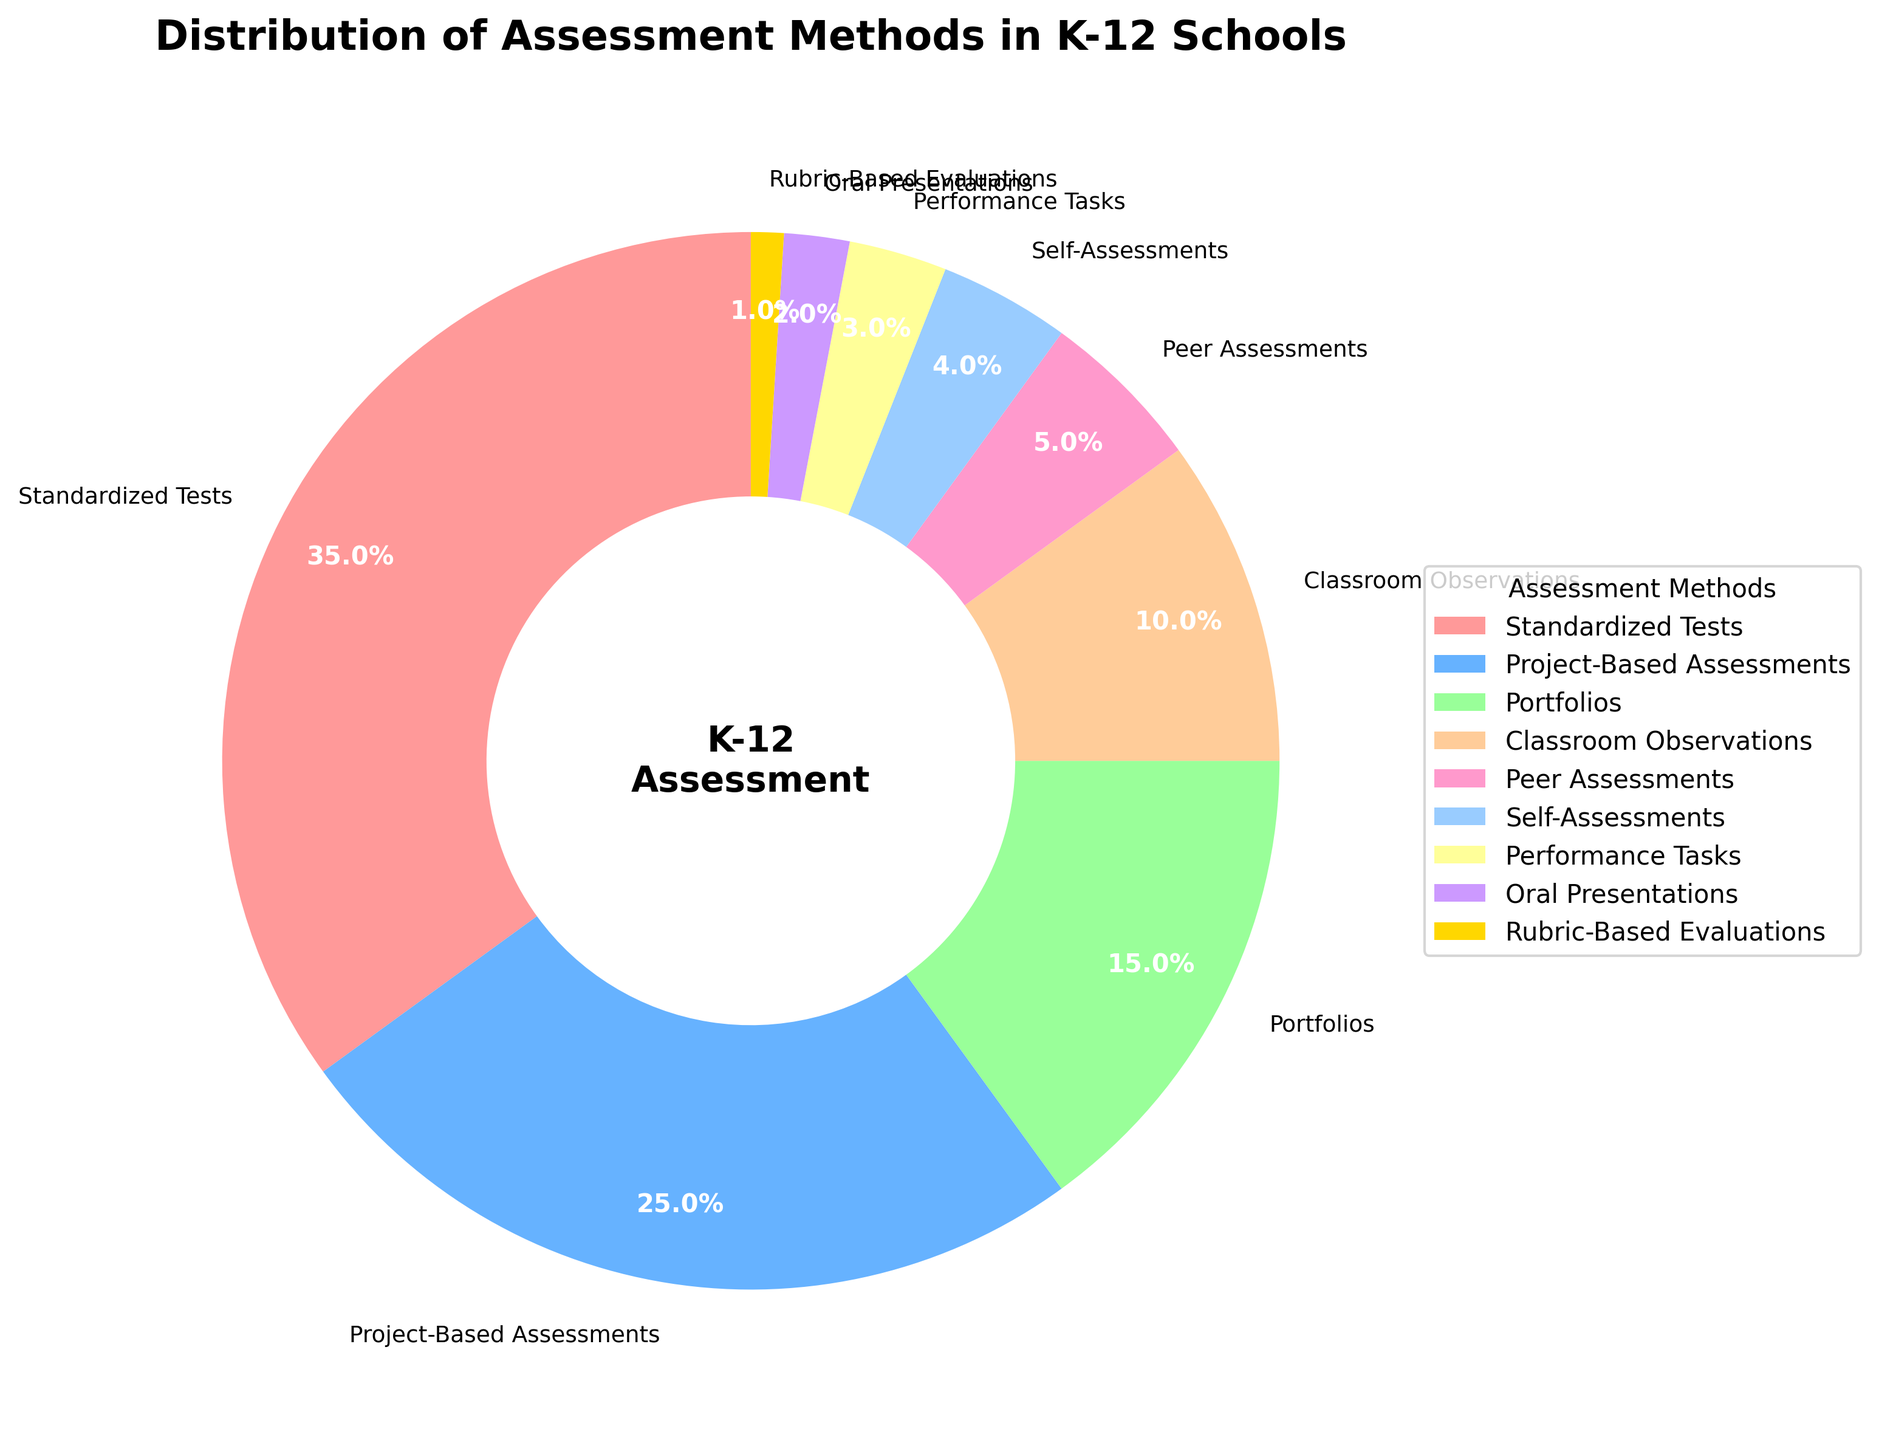What is the percentage of K-12 schools that use Standardized Tests for assessment? Standardized Tests takes up 35% of the assessment methods as indicated on the pie chart.
Answer: 35% What is the combined percentage of schools using Project-Based Assessments, Portfolios, and Classroom Observations? Adding up the percentages for Project-Based Assessments (25%), Portfolios (15%), and Classroom Observations (10%) gives us 25% + 15% + 10% = 50%.
Answer: 50% Which two assessment methods combined have a lower percentage than Standardized Tests alone? Performance Tasks (3%) combined with Oral Presentations (2%) equates to 3% + 2% = 5%, which is significantly lower than Standardized Tests (35%).
Answer: Performance Tasks and Oral Presentations How much more popular are Project-Based Assessments compared to Peer Assessments? Project-Based Assessments are at 25%, and Peer Assessments are at 5%. The difference is 25% - 5% = 20%.
Answer: 20% Which assessment method is least frequently used, and what is its percentage? According to the pie chart, Rubric-Based Evaluations are the least frequently used method at 1%.
Answer: Rubric-Based Evaluations at 1% If you combine the percentages of Self-Assessments, Performance Tasks, and Rubric-Based Evaluations, do they equal Classroom Observations? Self-Assessments are 4%, Performance Tasks are 3%, and Rubric-Based Evaluations are 1%. The total is 4% + 3% + 1% = 8%, which is less than Classroom Observations at 10%.
Answer: No Which assessment method has the second-highest percentage, and what is that percentage? Following Standardized Tests which are 35%, Project-Based Assessments have the second-highest percentage at 25%.
Answer: Project-Based Assessments at 25% What is the difference in percentage between Portfolios and Self-Assessments? Portfolios account for 15% and Self-Assessments are 4%. The difference is 15% - 4% = 11%.
Answer: 11% 